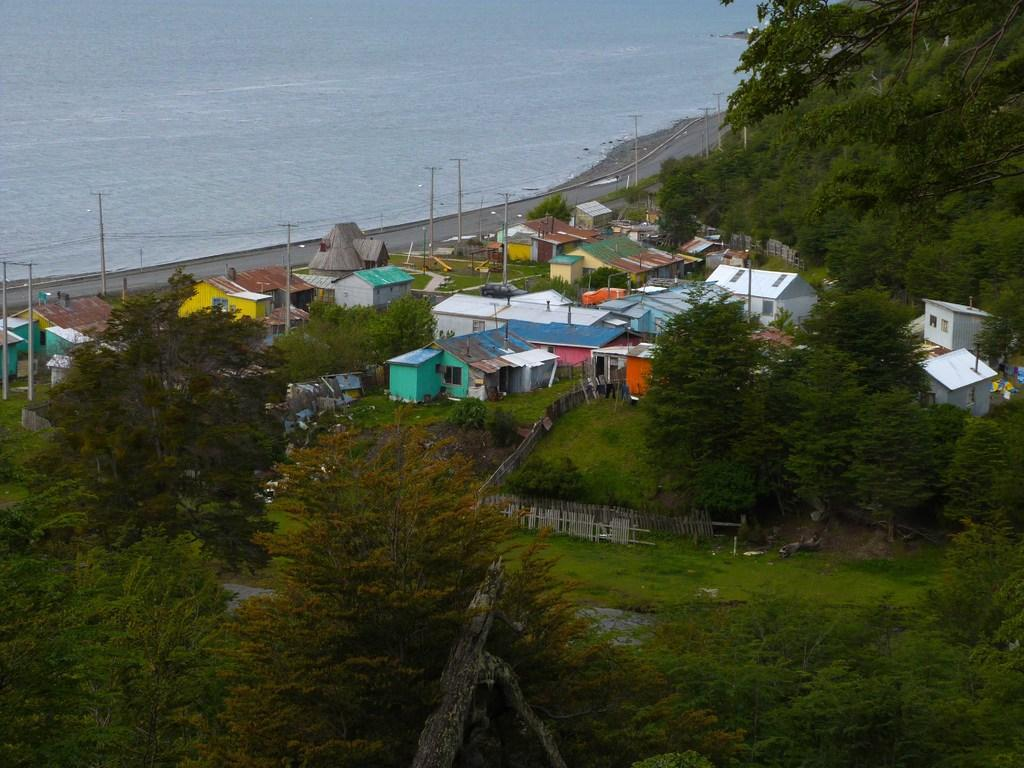What type of structures can be seen in the image? There are houses in the image. What is the main pathway visible in the image? There is a road in the image. What are the vertical structures in the image used for? The poles in the image are likely used for supporting wires or signs. What type of barrier is present in the image? There is a fence in the image. What type of vegetation is present in the image? There are trees and grass in the image. What natural element can be seen in the image? There is water visible in the image. What type of wound can be seen on the bird in the image? There is no bird present in the image, and therefore no wound can be observed. What type of badge is visible on the person in the image? There is no person present in the image, and therefore no badge can be observed. 